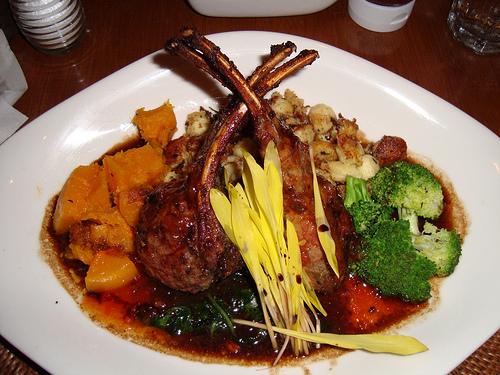Is this dessert?
Quick response, please. No. Does this meal look healthy?
Quick response, please. Yes. Is the meat burnt?
Short answer required. No. Is there gravity on the meat?
Answer briefly. No. Is the food plated symmetrically?
Short answer required. Yes. 